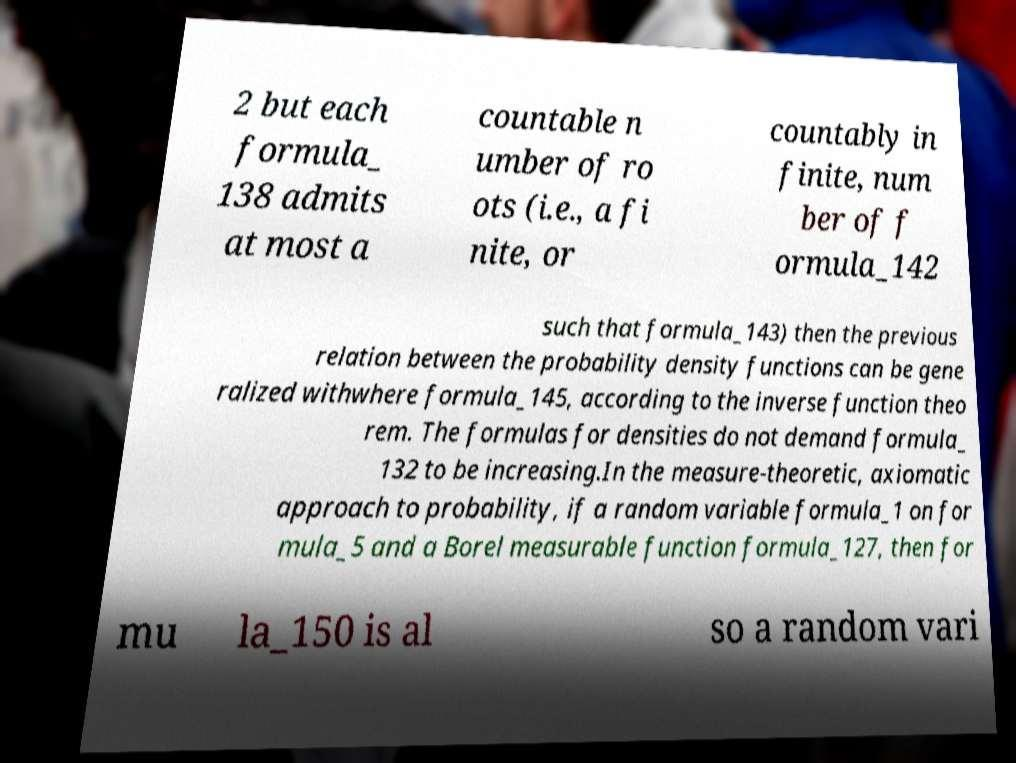I need the written content from this picture converted into text. Can you do that? 2 but each formula_ 138 admits at most a countable n umber of ro ots (i.e., a fi nite, or countably in finite, num ber of f ormula_142 such that formula_143) then the previous relation between the probability density functions can be gene ralized withwhere formula_145, according to the inverse function theo rem. The formulas for densities do not demand formula_ 132 to be increasing.In the measure-theoretic, axiomatic approach to probability, if a random variable formula_1 on for mula_5 and a Borel measurable function formula_127, then for mu la_150 is al so a random vari 